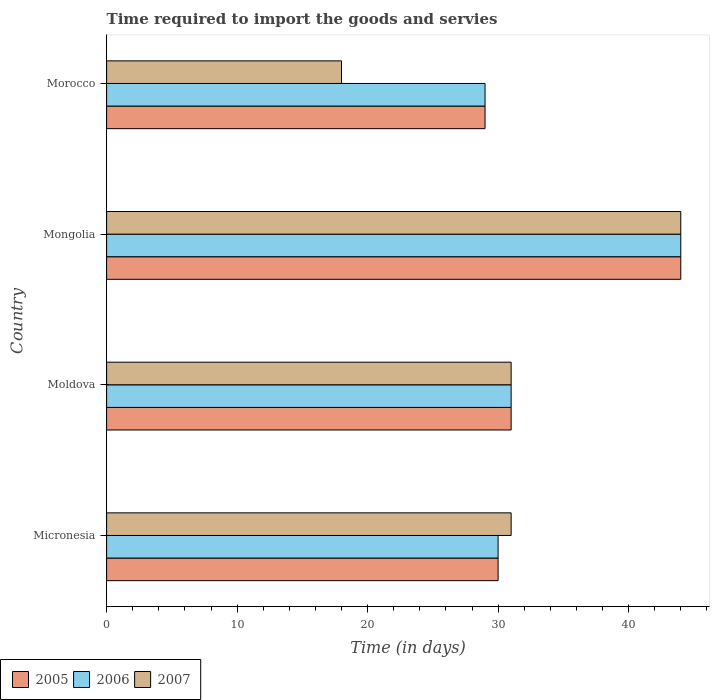How many different coloured bars are there?
Offer a terse response. 3. Are the number of bars on each tick of the Y-axis equal?
Ensure brevity in your answer.  Yes. How many bars are there on the 2nd tick from the top?
Your answer should be very brief. 3. How many bars are there on the 2nd tick from the bottom?
Ensure brevity in your answer.  3. What is the label of the 3rd group of bars from the top?
Your answer should be very brief. Moldova. What is the number of days required to import the goods and services in 2006 in Mongolia?
Offer a very short reply. 44. Across all countries, what is the maximum number of days required to import the goods and services in 2007?
Offer a terse response. 44. In which country was the number of days required to import the goods and services in 2007 maximum?
Provide a succinct answer. Mongolia. In which country was the number of days required to import the goods and services in 2007 minimum?
Keep it short and to the point. Morocco. What is the total number of days required to import the goods and services in 2005 in the graph?
Make the answer very short. 134. What is the difference between the number of days required to import the goods and services in 2007 and number of days required to import the goods and services in 2005 in Morocco?
Your answer should be very brief. -11. What is the ratio of the number of days required to import the goods and services in 2005 in Mongolia to that in Morocco?
Make the answer very short. 1.52. Is the number of days required to import the goods and services in 2006 in Micronesia less than that in Moldova?
Give a very brief answer. Yes. What is the difference between the highest and the second highest number of days required to import the goods and services in 2007?
Your answer should be very brief. 13. Is the sum of the number of days required to import the goods and services in 2005 in Micronesia and Moldova greater than the maximum number of days required to import the goods and services in 2006 across all countries?
Keep it short and to the point. Yes. What does the 3rd bar from the top in Mongolia represents?
Ensure brevity in your answer.  2005. What does the 3rd bar from the bottom in Moldova represents?
Offer a very short reply. 2007. How many bars are there?
Keep it short and to the point. 12. Are all the bars in the graph horizontal?
Keep it short and to the point. Yes. Are the values on the major ticks of X-axis written in scientific E-notation?
Offer a terse response. No. Does the graph contain any zero values?
Ensure brevity in your answer.  No. Where does the legend appear in the graph?
Provide a short and direct response. Bottom left. What is the title of the graph?
Keep it short and to the point. Time required to import the goods and servies. Does "2013" appear as one of the legend labels in the graph?
Ensure brevity in your answer.  No. What is the label or title of the X-axis?
Your answer should be compact. Time (in days). What is the label or title of the Y-axis?
Make the answer very short. Country. What is the Time (in days) of 2007 in Micronesia?
Give a very brief answer. 31. What is the Time (in days) in 2005 in Moldova?
Provide a succinct answer. 31. What is the Time (in days) of 2006 in Moldova?
Provide a short and direct response. 31. What is the Time (in days) in 2005 in Mongolia?
Your response must be concise. 44. What is the Time (in days) of 2007 in Mongolia?
Your response must be concise. 44. What is the Time (in days) of 2006 in Morocco?
Offer a terse response. 29. Across all countries, what is the maximum Time (in days) in 2006?
Your answer should be very brief. 44. Across all countries, what is the maximum Time (in days) of 2007?
Give a very brief answer. 44. Across all countries, what is the minimum Time (in days) of 2007?
Ensure brevity in your answer.  18. What is the total Time (in days) in 2005 in the graph?
Ensure brevity in your answer.  134. What is the total Time (in days) of 2006 in the graph?
Give a very brief answer. 134. What is the total Time (in days) of 2007 in the graph?
Make the answer very short. 124. What is the difference between the Time (in days) of 2007 in Micronesia and that in Moldova?
Keep it short and to the point. 0. What is the difference between the Time (in days) in 2007 in Micronesia and that in Mongolia?
Your response must be concise. -13. What is the difference between the Time (in days) of 2006 in Micronesia and that in Morocco?
Offer a terse response. 1. What is the difference between the Time (in days) of 2007 in Micronesia and that in Morocco?
Offer a very short reply. 13. What is the difference between the Time (in days) of 2007 in Moldova and that in Mongolia?
Provide a short and direct response. -13. What is the difference between the Time (in days) of 2005 in Moldova and that in Morocco?
Offer a very short reply. 2. What is the difference between the Time (in days) in 2005 in Micronesia and the Time (in days) in 2006 in Moldova?
Offer a very short reply. -1. What is the difference between the Time (in days) of 2005 in Micronesia and the Time (in days) of 2006 in Mongolia?
Provide a succinct answer. -14. What is the difference between the Time (in days) in 2005 in Moldova and the Time (in days) in 2006 in Mongolia?
Offer a very short reply. -13. What is the difference between the Time (in days) of 2005 in Moldova and the Time (in days) of 2007 in Mongolia?
Offer a terse response. -13. What is the difference between the Time (in days) of 2005 in Moldova and the Time (in days) of 2007 in Morocco?
Make the answer very short. 13. What is the difference between the Time (in days) in 2006 in Mongolia and the Time (in days) in 2007 in Morocco?
Your answer should be very brief. 26. What is the average Time (in days) in 2005 per country?
Give a very brief answer. 33.5. What is the average Time (in days) of 2006 per country?
Make the answer very short. 33.5. What is the average Time (in days) in 2007 per country?
Keep it short and to the point. 31. What is the difference between the Time (in days) of 2005 and Time (in days) of 2006 in Micronesia?
Ensure brevity in your answer.  0. What is the difference between the Time (in days) in 2006 and Time (in days) in 2007 in Micronesia?
Your answer should be compact. -1. What is the difference between the Time (in days) in 2005 and Time (in days) in 2006 in Moldova?
Your answer should be compact. 0. What is the difference between the Time (in days) of 2006 and Time (in days) of 2007 in Moldova?
Make the answer very short. 0. What is the difference between the Time (in days) of 2005 and Time (in days) of 2007 in Mongolia?
Offer a terse response. 0. What is the ratio of the Time (in days) of 2005 in Micronesia to that in Mongolia?
Give a very brief answer. 0.68. What is the ratio of the Time (in days) of 2006 in Micronesia to that in Mongolia?
Offer a terse response. 0.68. What is the ratio of the Time (in days) of 2007 in Micronesia to that in Mongolia?
Offer a very short reply. 0.7. What is the ratio of the Time (in days) of 2005 in Micronesia to that in Morocco?
Your answer should be compact. 1.03. What is the ratio of the Time (in days) in 2006 in Micronesia to that in Morocco?
Give a very brief answer. 1.03. What is the ratio of the Time (in days) of 2007 in Micronesia to that in Morocco?
Make the answer very short. 1.72. What is the ratio of the Time (in days) of 2005 in Moldova to that in Mongolia?
Provide a short and direct response. 0.7. What is the ratio of the Time (in days) of 2006 in Moldova to that in Mongolia?
Keep it short and to the point. 0.7. What is the ratio of the Time (in days) in 2007 in Moldova to that in Mongolia?
Ensure brevity in your answer.  0.7. What is the ratio of the Time (in days) in 2005 in Moldova to that in Morocco?
Your answer should be compact. 1.07. What is the ratio of the Time (in days) in 2006 in Moldova to that in Morocco?
Provide a succinct answer. 1.07. What is the ratio of the Time (in days) in 2007 in Moldova to that in Morocco?
Keep it short and to the point. 1.72. What is the ratio of the Time (in days) in 2005 in Mongolia to that in Morocco?
Keep it short and to the point. 1.52. What is the ratio of the Time (in days) of 2006 in Mongolia to that in Morocco?
Your answer should be very brief. 1.52. What is the ratio of the Time (in days) in 2007 in Mongolia to that in Morocco?
Your response must be concise. 2.44. What is the difference between the highest and the second highest Time (in days) in 2006?
Provide a succinct answer. 13. What is the difference between the highest and the second highest Time (in days) of 2007?
Your response must be concise. 13. What is the difference between the highest and the lowest Time (in days) of 2006?
Make the answer very short. 15. 